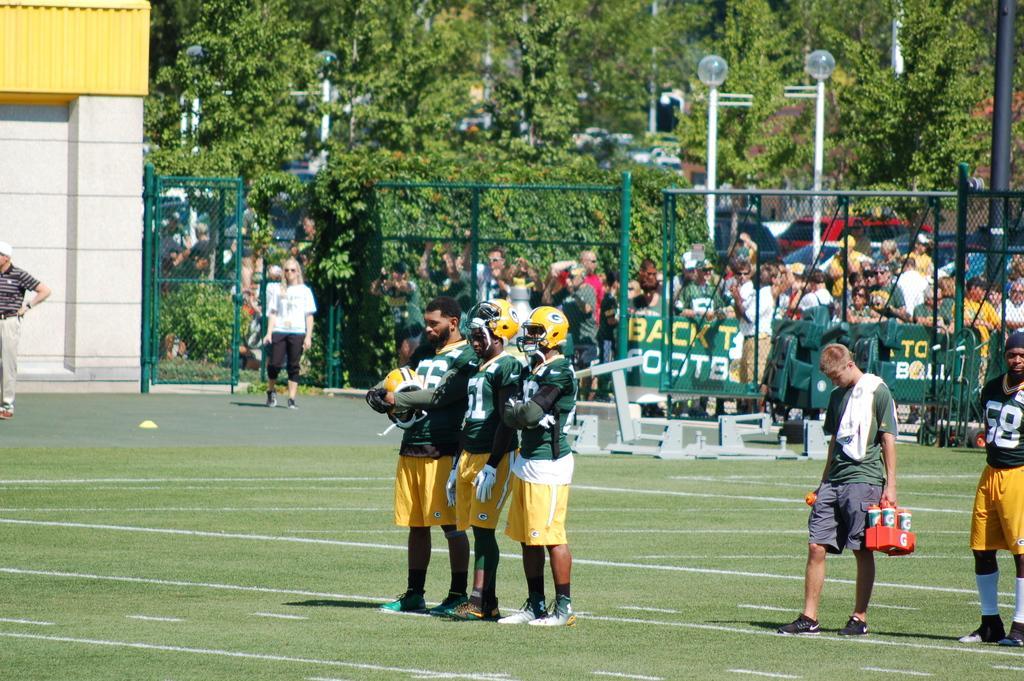Could you give a brief overview of what you see in this image? In this image I can see the group of people standing on the ground. In the background I can see the net fence, boards and many people with different color dresses. I can also see poles and many trees. 